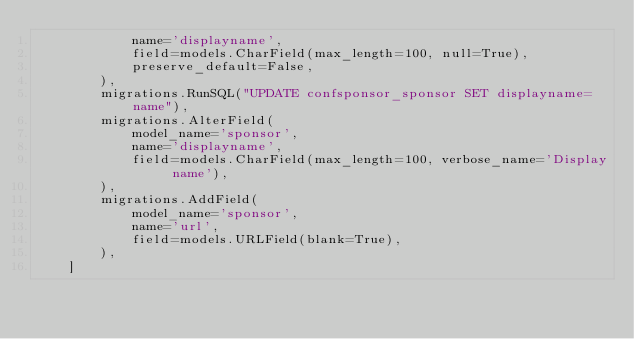<code> <loc_0><loc_0><loc_500><loc_500><_Python_>            name='displayname',
            field=models.CharField(max_length=100, null=True),
            preserve_default=False,
        ),
        migrations.RunSQL("UPDATE confsponsor_sponsor SET displayname=name"),
        migrations.AlterField(
            model_name='sponsor',
            name='displayname',
            field=models.CharField(max_length=100, verbose_name='Display name'),
        ),
        migrations.AddField(
            model_name='sponsor',
            name='url',
            field=models.URLField(blank=True),
        ),
    ]
</code> 